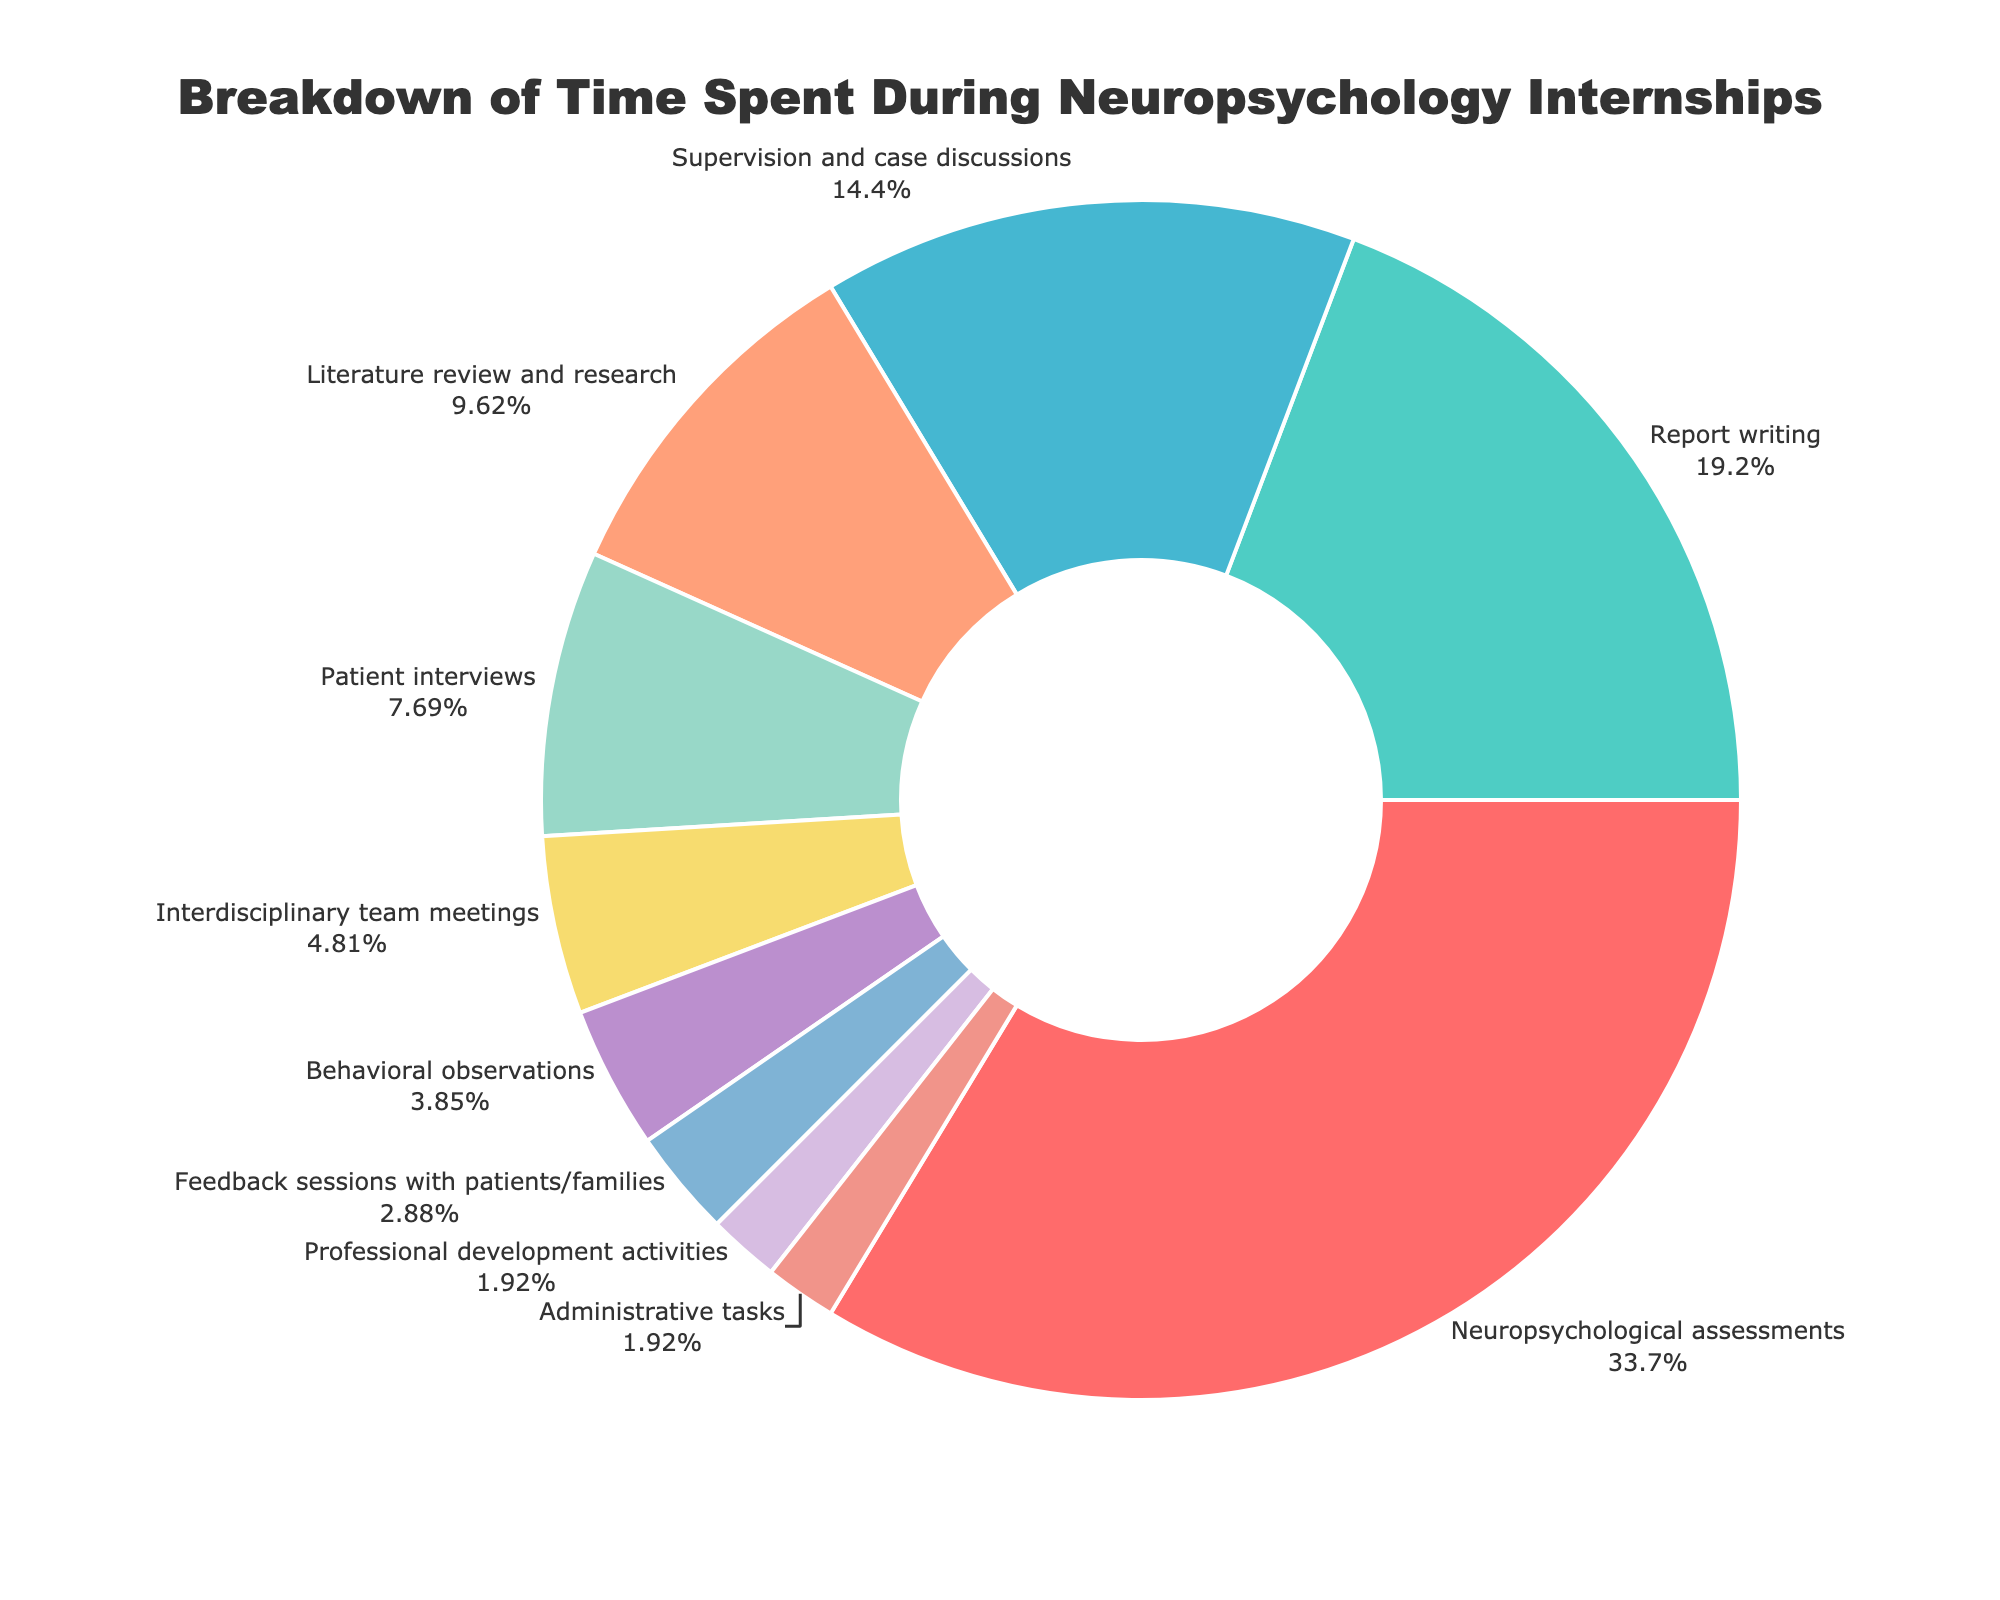Which activity takes up the greatest percentage of time during neuropsychology internships? The pie chart shows that Neuropsychological assessments take up the largest portion of the chart.
Answer: Neuropsychological assessments How much more time is spent on Neuropsychological assessments compared to Report writing? The time spent on Neuropsychological assessments is 35%, and the time spent on Report writing is 20%. The difference is 35% - 20%.
Answer: 15% What is the combined percentage of time spent on Supervision and case discussions and Literature review and research? The time spent on Supervision and case discussions is 15%, and the time spent on Literature review and research is 10%. The combined percentage is 15% + 10%.
Answer: 25% Which activity occupies the smallest percentage of time and what is that percentage? According to the pie chart, Professional development activities and Administrative tasks both occupy the smallest portion, which is 2%.
Answer: 2% Is the time spent on Behavioral observations more or less than that spent on Patient interviews? The percentage for Behavioral observations is 4%, and for Patient interviews, it is 8%. 4% is less than 8%.
Answer: Less By how much does the percentage of time spent on Feedback sessions with patients/families differ from Interdisciplinary team meetings? The time spent on Feedback sessions with patients/families is 3%, and the time spent on Interdisciplinary team meetings is 5%. The difference is 5% - 3%.
Answer: 2% How does the time spent on Report writing compare to the time spent on Supervision and case discussions? Report writing takes up 20% of the time, whereas Supervision and case discussions take up 15%. Hence, Report writing takes up 5% more time.
Answer: 5% more What is the total percentage of time spent on activities other than Neuropsychological assessments and Report writing? The percentage for Neuropsychological assessments is 35% and for Report writing is 20%. The total percentage for other activities is 100% - 35% - 20%.
Answer: 45% Which activity represented by a specific color (e.g., blue) takes the least amount of time? Assuming the pie chart shows various colors with each segment, looking at the 2% segments, Professional development activities or Administrative tasks should be the activities denoted by the smallest section's colors.
Answer: Professional development activities/Administrative tasks 